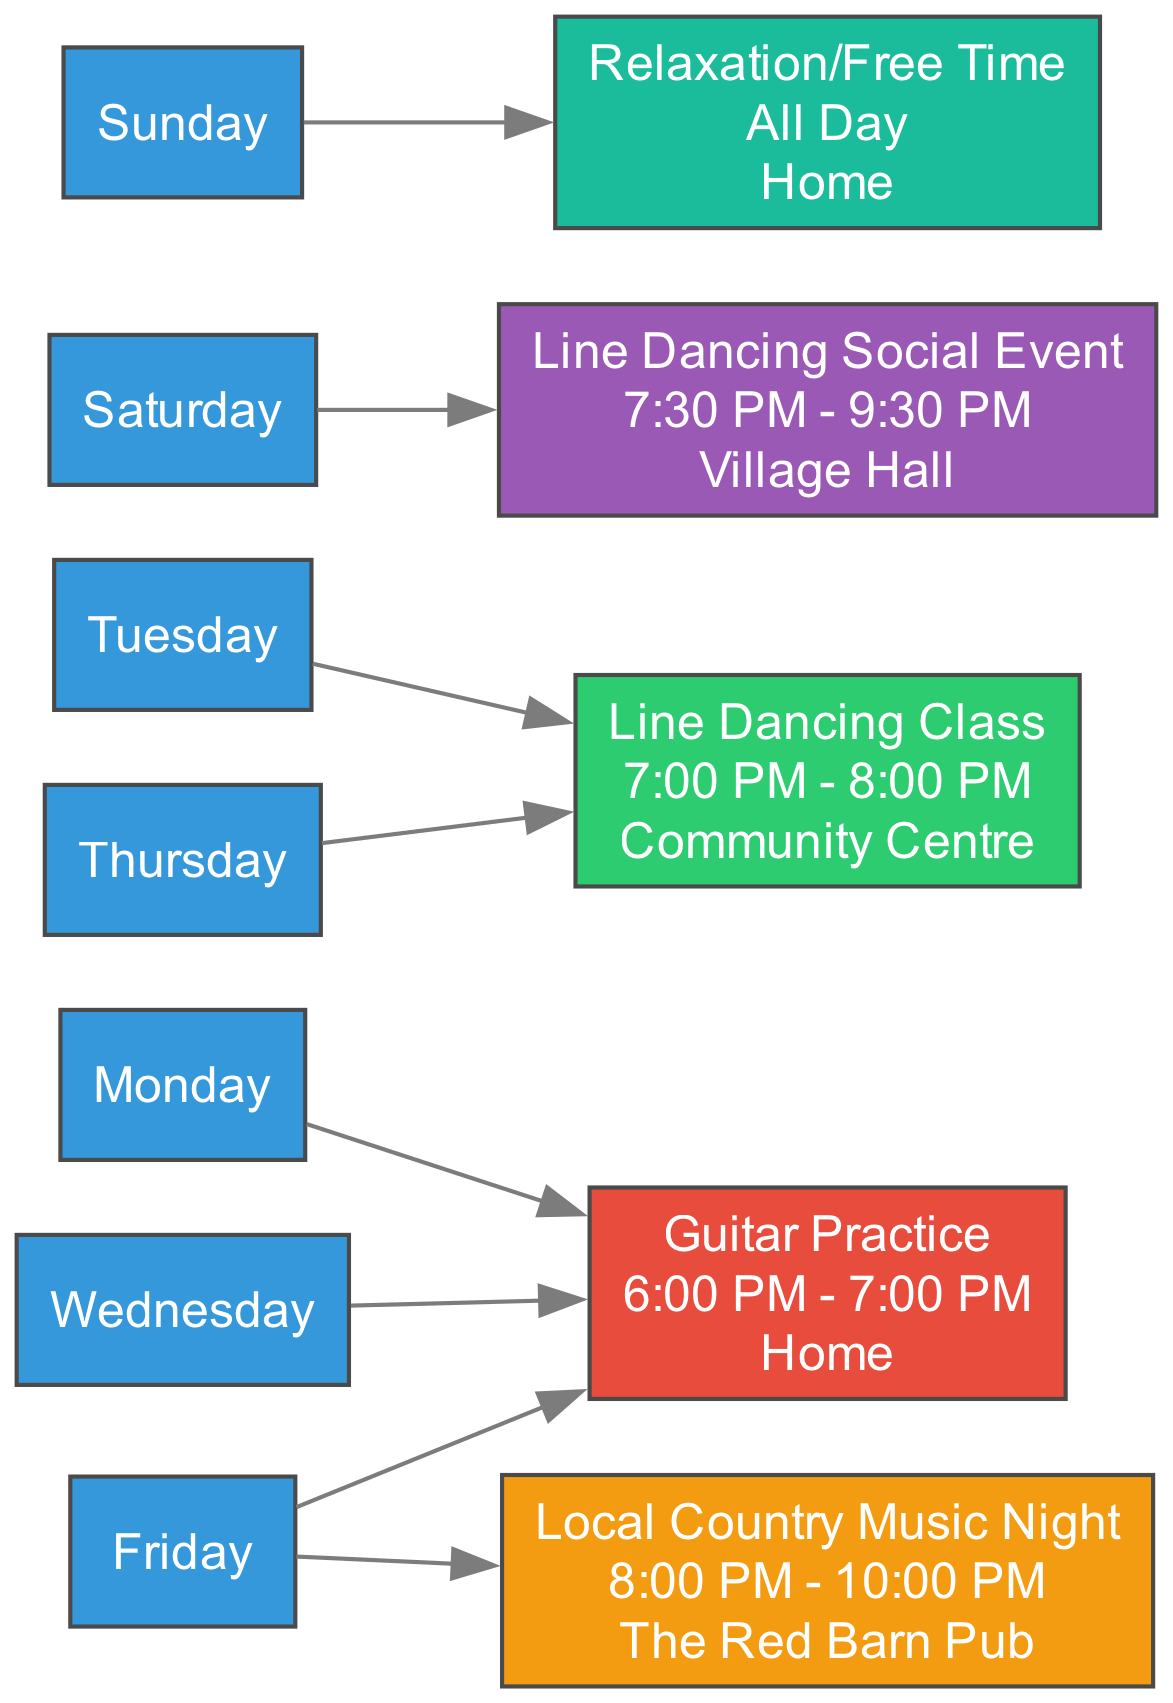What activities are scheduled for Friday? According to the diagram, Friday has two activities: Guitar Practice from 6:00 PM to 7:00 PM and Local Country Music Night from 8:00 PM to 10:00 PM.
Answer: Guitar Practice, Local Country Music Night How long is the Line Dancing Class? The Line Dancing Class is scheduled for 1 hour from 7:00 PM to 8:00 PM on both Tuesday and Thursday.
Answer: 1 hour Which day has the Line Dancing Social Event? The Line Dancing Social Event is specifically noted to take place on Saturday according to the information in the diagram.
Answer: Saturday What is the location for Guitar Practice? The Guitar Practice, as listed in the diagram, takes place at Home.
Answer: Home How many activities occur on Saturday? There are two activities scheduled for Saturday: Line Dancing Social Event from 7:30 PM to 9:30 PM and no other activities are mentioned for that day.
Answer: 1 activity On which days does the Relaxation/Free Time occur? Relaxation/Free Time is designated for Sunday, and according to the diagram, it spans the entire day with no specific time indicated.
Answer: Sunday What is the first activity of the week? The first activity listed in the diagram for the week is Guitar Practice on Monday, from 6:00 PM to 7:00 PM.
Answer: Guitar Practice How many days of the week have activities scheduled? From the diagram, activities are scheduled for six days of the week: Monday, Tuesday, Wednesday, Thursday, Friday, and Saturday. Sunday is reserved for Relaxation/Free Time with no structured activities.
Answer: 6 days Which activity takes place at the Village Hall? The Line Dancing Social Event is the activity that occurs at the Village Hall on Saturday evening according to the diagram details.
Answer: Line Dancing Social Event 